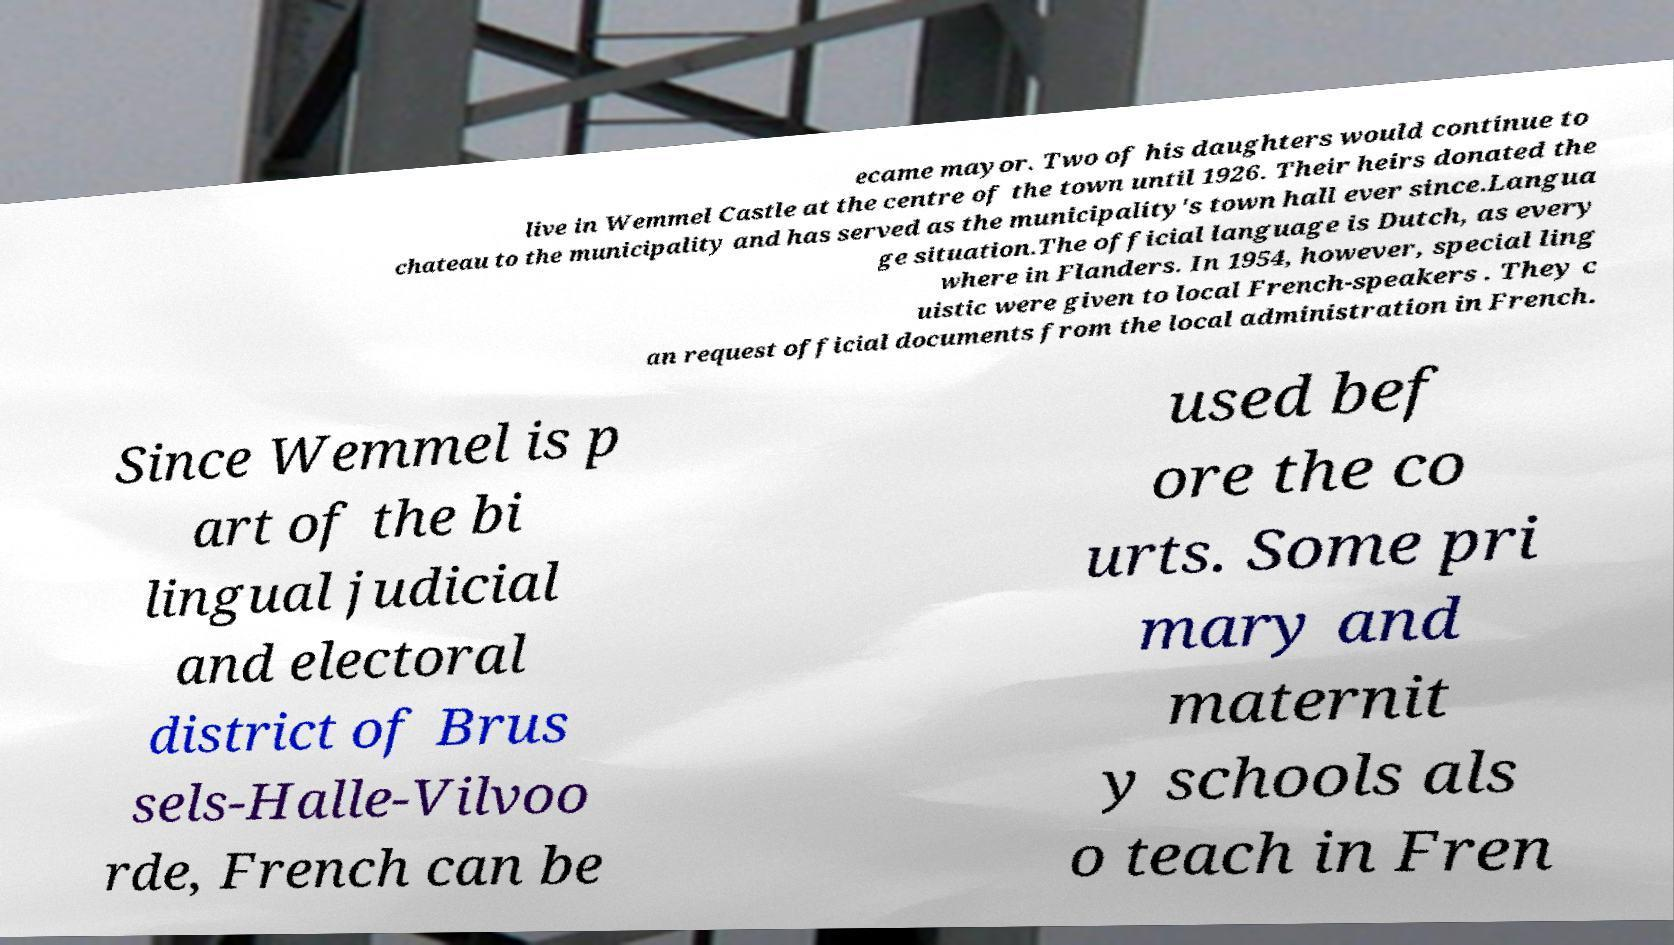Please read and relay the text visible in this image. What does it say? ecame mayor. Two of his daughters would continue to live in Wemmel Castle at the centre of the town until 1926. Their heirs donated the chateau to the municipality and has served as the municipality's town hall ever since.Langua ge situation.The official language is Dutch, as every where in Flanders. In 1954, however, special ling uistic were given to local French-speakers . They c an request official documents from the local administration in French. Since Wemmel is p art of the bi lingual judicial and electoral district of Brus sels-Halle-Vilvoo rde, French can be used bef ore the co urts. Some pri mary and maternit y schools als o teach in Fren 